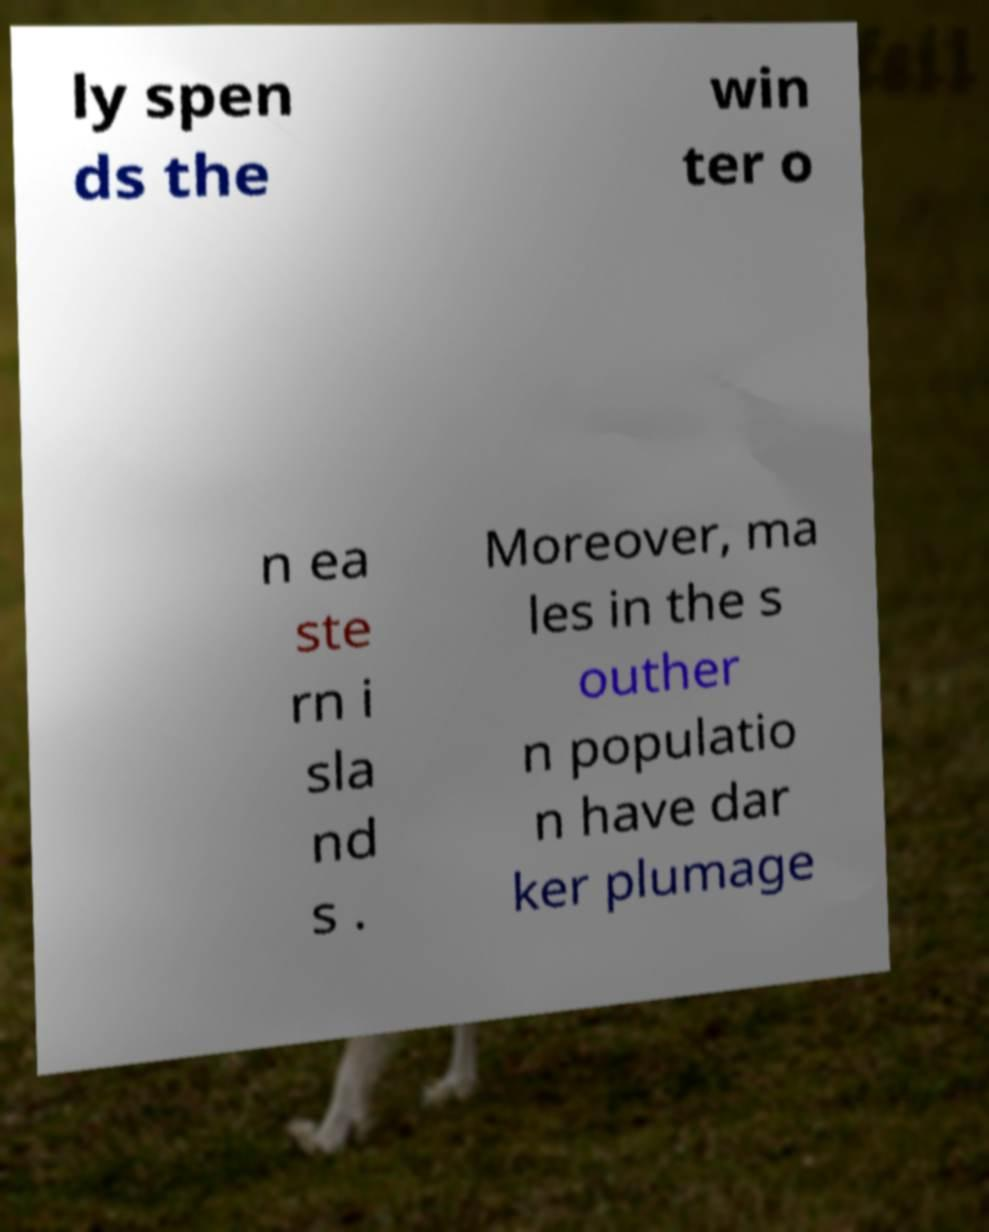Could you assist in decoding the text presented in this image and type it out clearly? ly spen ds the win ter o n ea ste rn i sla nd s . Moreover, ma les in the s outher n populatio n have dar ker plumage 